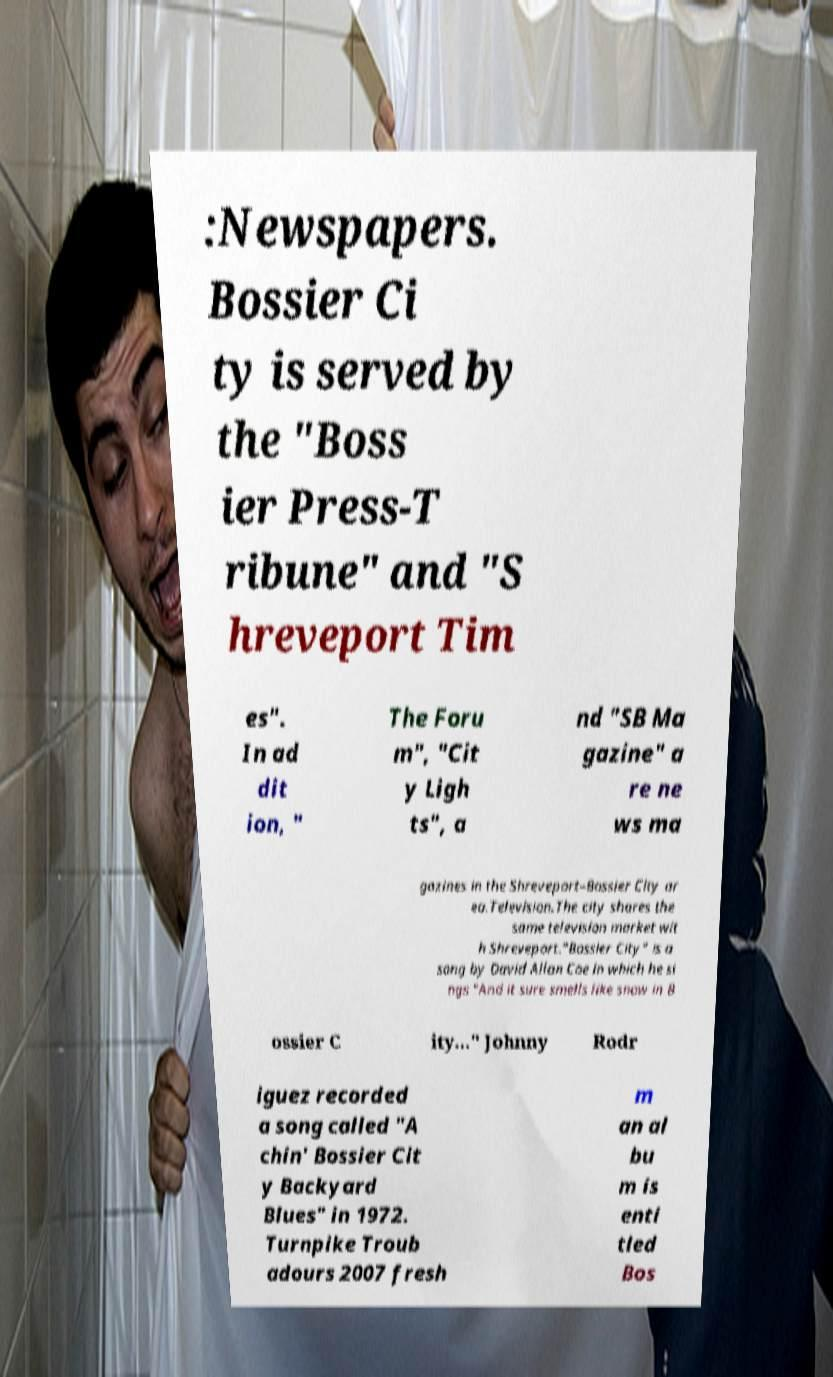Can you accurately transcribe the text from the provided image for me? :Newspapers. Bossier Ci ty is served by the "Boss ier Press-T ribune" and "S hreveport Tim es". In ad dit ion, " The Foru m", "Cit y Ligh ts", a nd "SB Ma gazine" a re ne ws ma gazines in the Shreveport–Bossier City ar ea.Television.The city shares the same television market wit h Shreveport."Bossier City" is a song by David Allan Coe in which he si ngs "And it sure smells like snow in B ossier C ity..." Johnny Rodr iguez recorded a song called "A chin' Bossier Cit y Backyard Blues" in 1972. Turnpike Troub adours 2007 fresh m an al bu m is enti tled Bos 